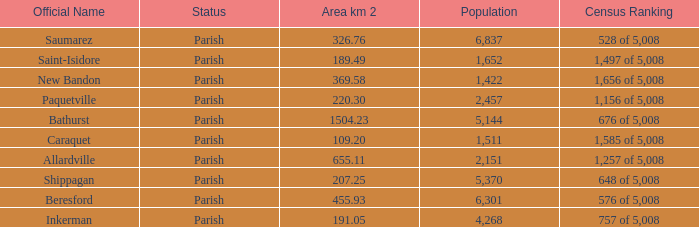What is the Area of the Saint-Isidore Parish with a Population smaller than 4,268? 189.49. 